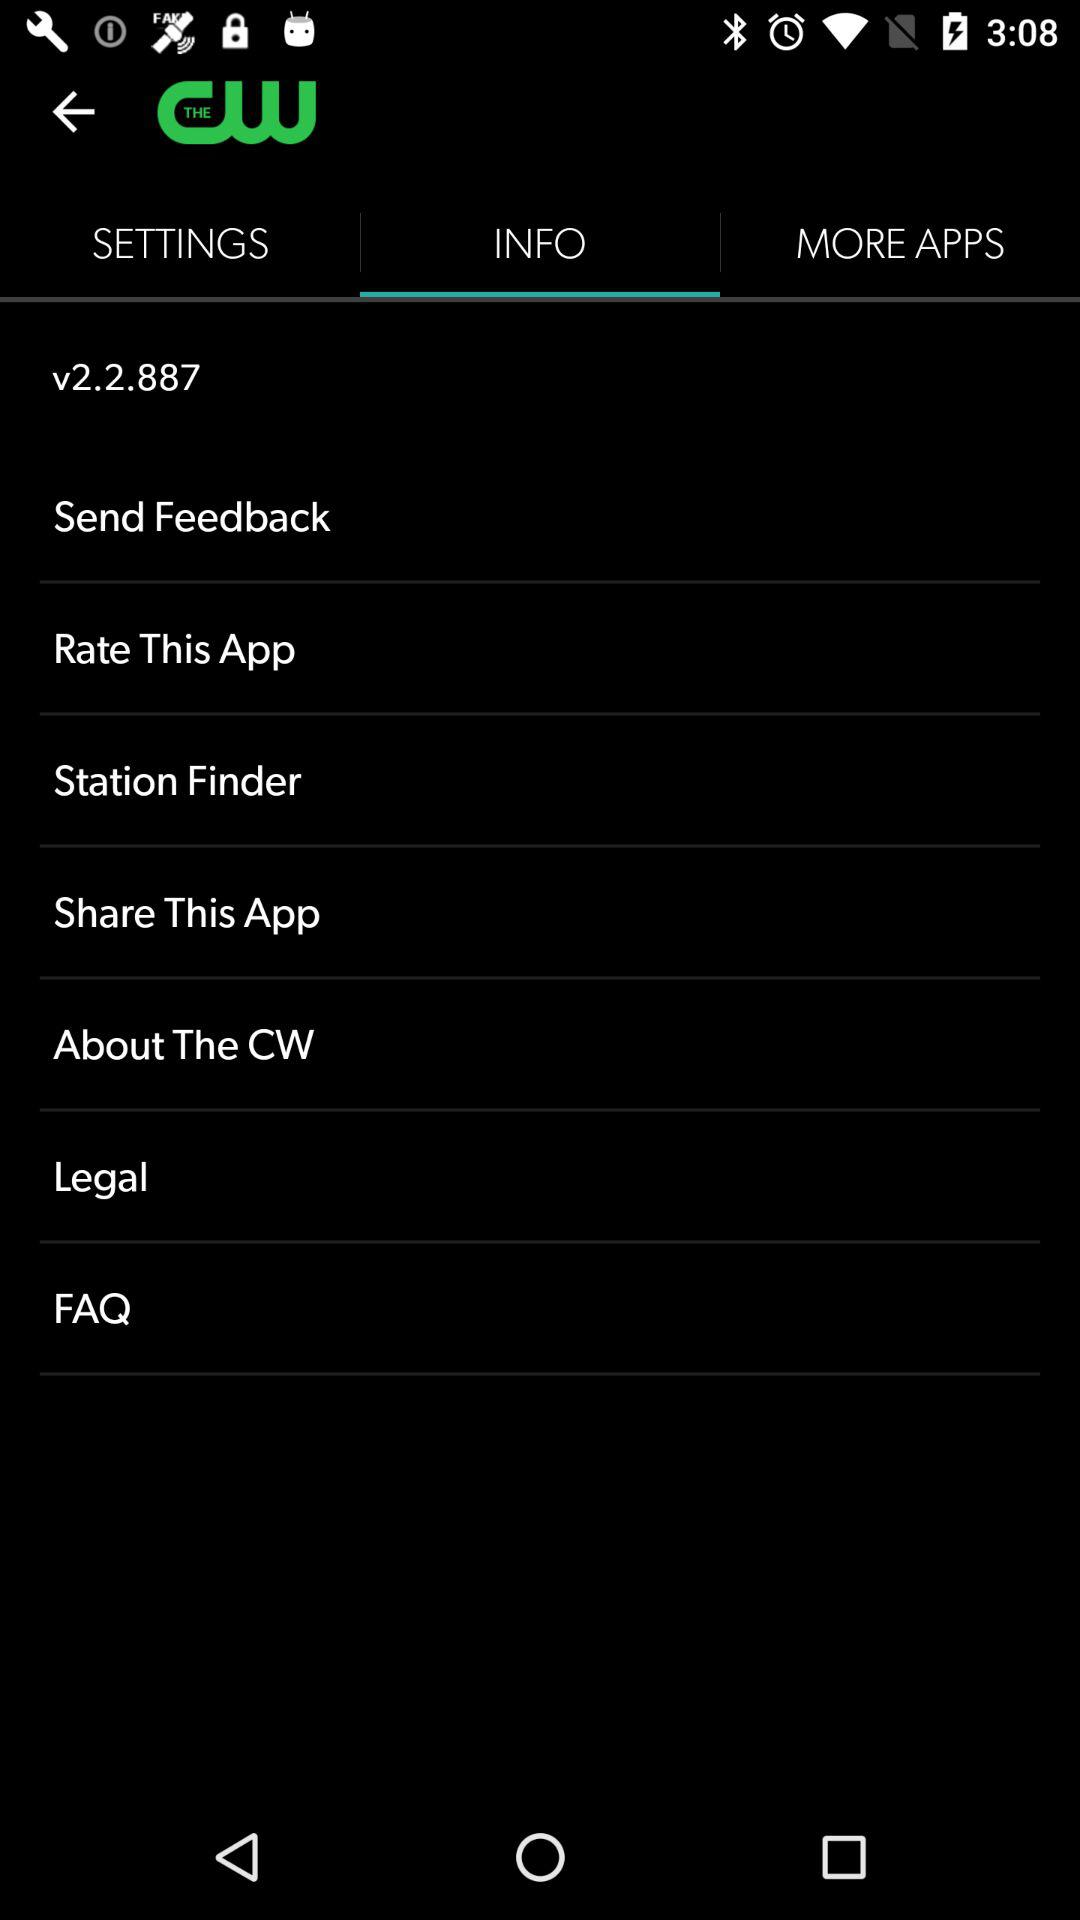Which tab has been selected? The selected tab is "INFO". 